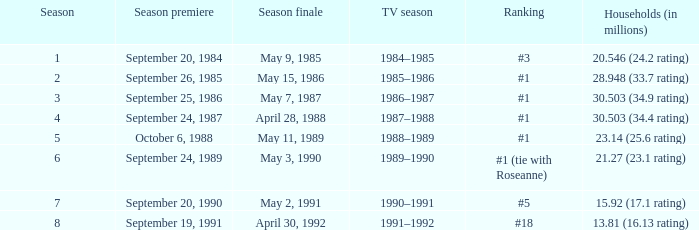Which TV season has a Season smaller than 8, and a Household (in millions) of 15.92 (17.1 rating)? 1990–1991. 